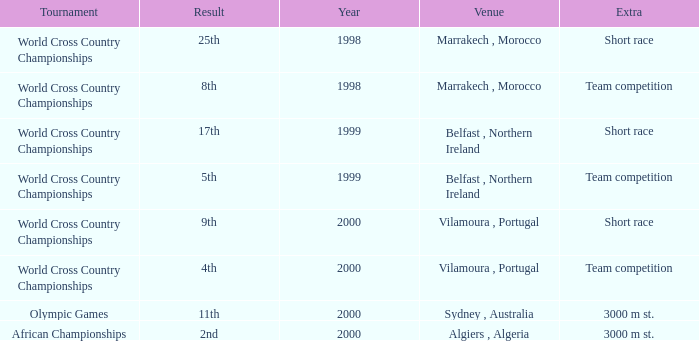Tell me the highest year for result of 9th 2000.0. 